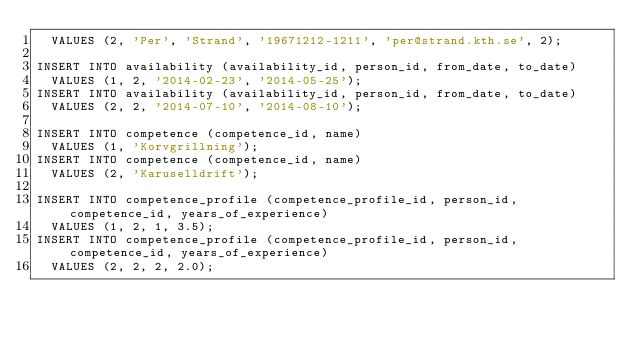<code> <loc_0><loc_0><loc_500><loc_500><_SQL_>	VALUES (2, 'Per', 'Strand', '19671212-1211', 'per@strand.kth.se', 2);

INSERT INTO availability (availability_id, person_id, from_date, to_date)
	VALUES (1, 2, '2014-02-23', '2014-05-25');
INSERT INTO availability (availability_id, person_id, from_date, to_date)
	VALUES (2, 2, '2014-07-10', '2014-08-10');

INSERT INTO competence (competence_id, name)
	VALUES (1, 'Korvgrillning');
INSERT INTO competence (competence_id, name)
	VALUES (2, 'Karuselldrift');

INSERT INTO competence_profile (competence_profile_id, person_id,competence_id, years_of_experience)
	VALUES (1, 2, 1, 3.5);
INSERT INTO competence_profile (competence_profile_id, person_id,competence_id, years_of_experience)
	VALUES (2, 2, 2, 2.0);
</code> 